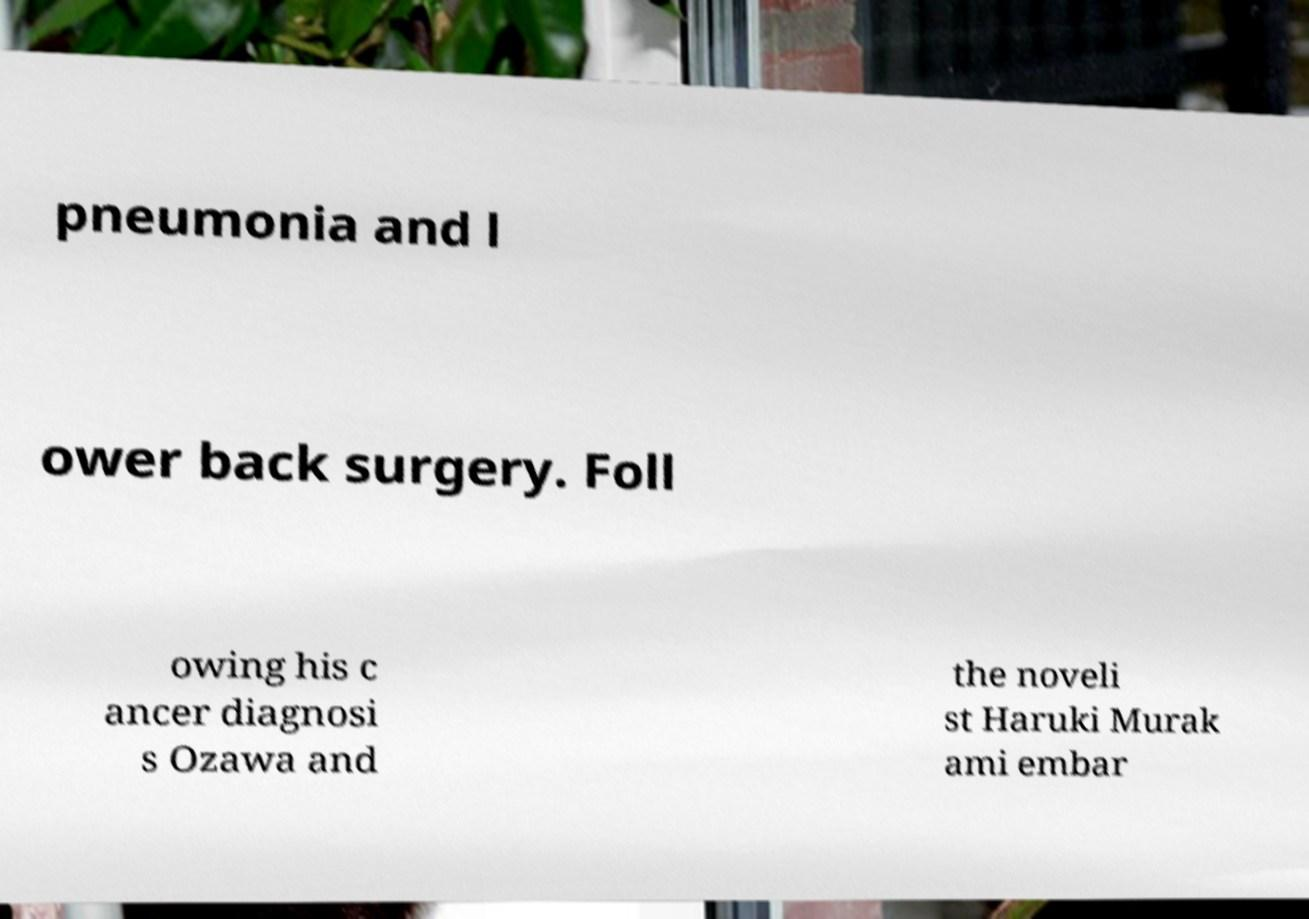Could you extract and type out the text from this image? pneumonia and l ower back surgery. Foll owing his c ancer diagnosi s Ozawa and the noveli st Haruki Murak ami embar 